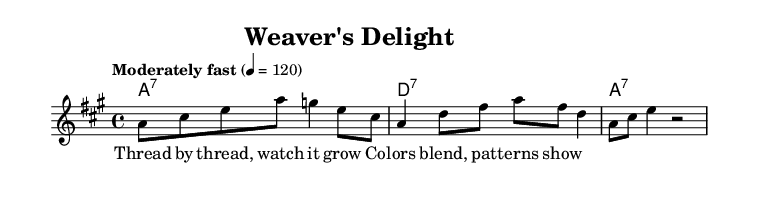What is the key signature of this music? The key signature is A major, which has three sharps: F#, C#, and G#.
Answer: A major What is the time signature for this piece? The time signature is indicated as 4/4, meaning there are four beats in each measure and the quarter note gets one beat.
Answer: 4/4 What tempo is marked for this piece? The tempo marking is "Moderately fast" with a metronome marking of 120 beats per minute, indicating a brisk pace.
Answer: Moderately fast, 120 How many measures are in the melody? Counting the measures shown in the melody, there are a total of three measures present.
Answer: 3 What is the first lyric of the verse? The first lyric of the verse is "Thread by thread," which shows the beginning of the lyrical content accompanying the melody.
Answer: Thread by thread What type of seventh chords are used in the harmonies? The harmonies consist of A dominant seventh chords and D dominant seventh chords, as indicated by the chord names.
Answer: Dominant seventh chords Why is this piece categorized as a blues track? This piece is classified as blues due to its use of a traditional blues structure, repetitive lyrical phrasing, and a focus on personal expression through simple but emotive melodies.
Answer: Blues structure 